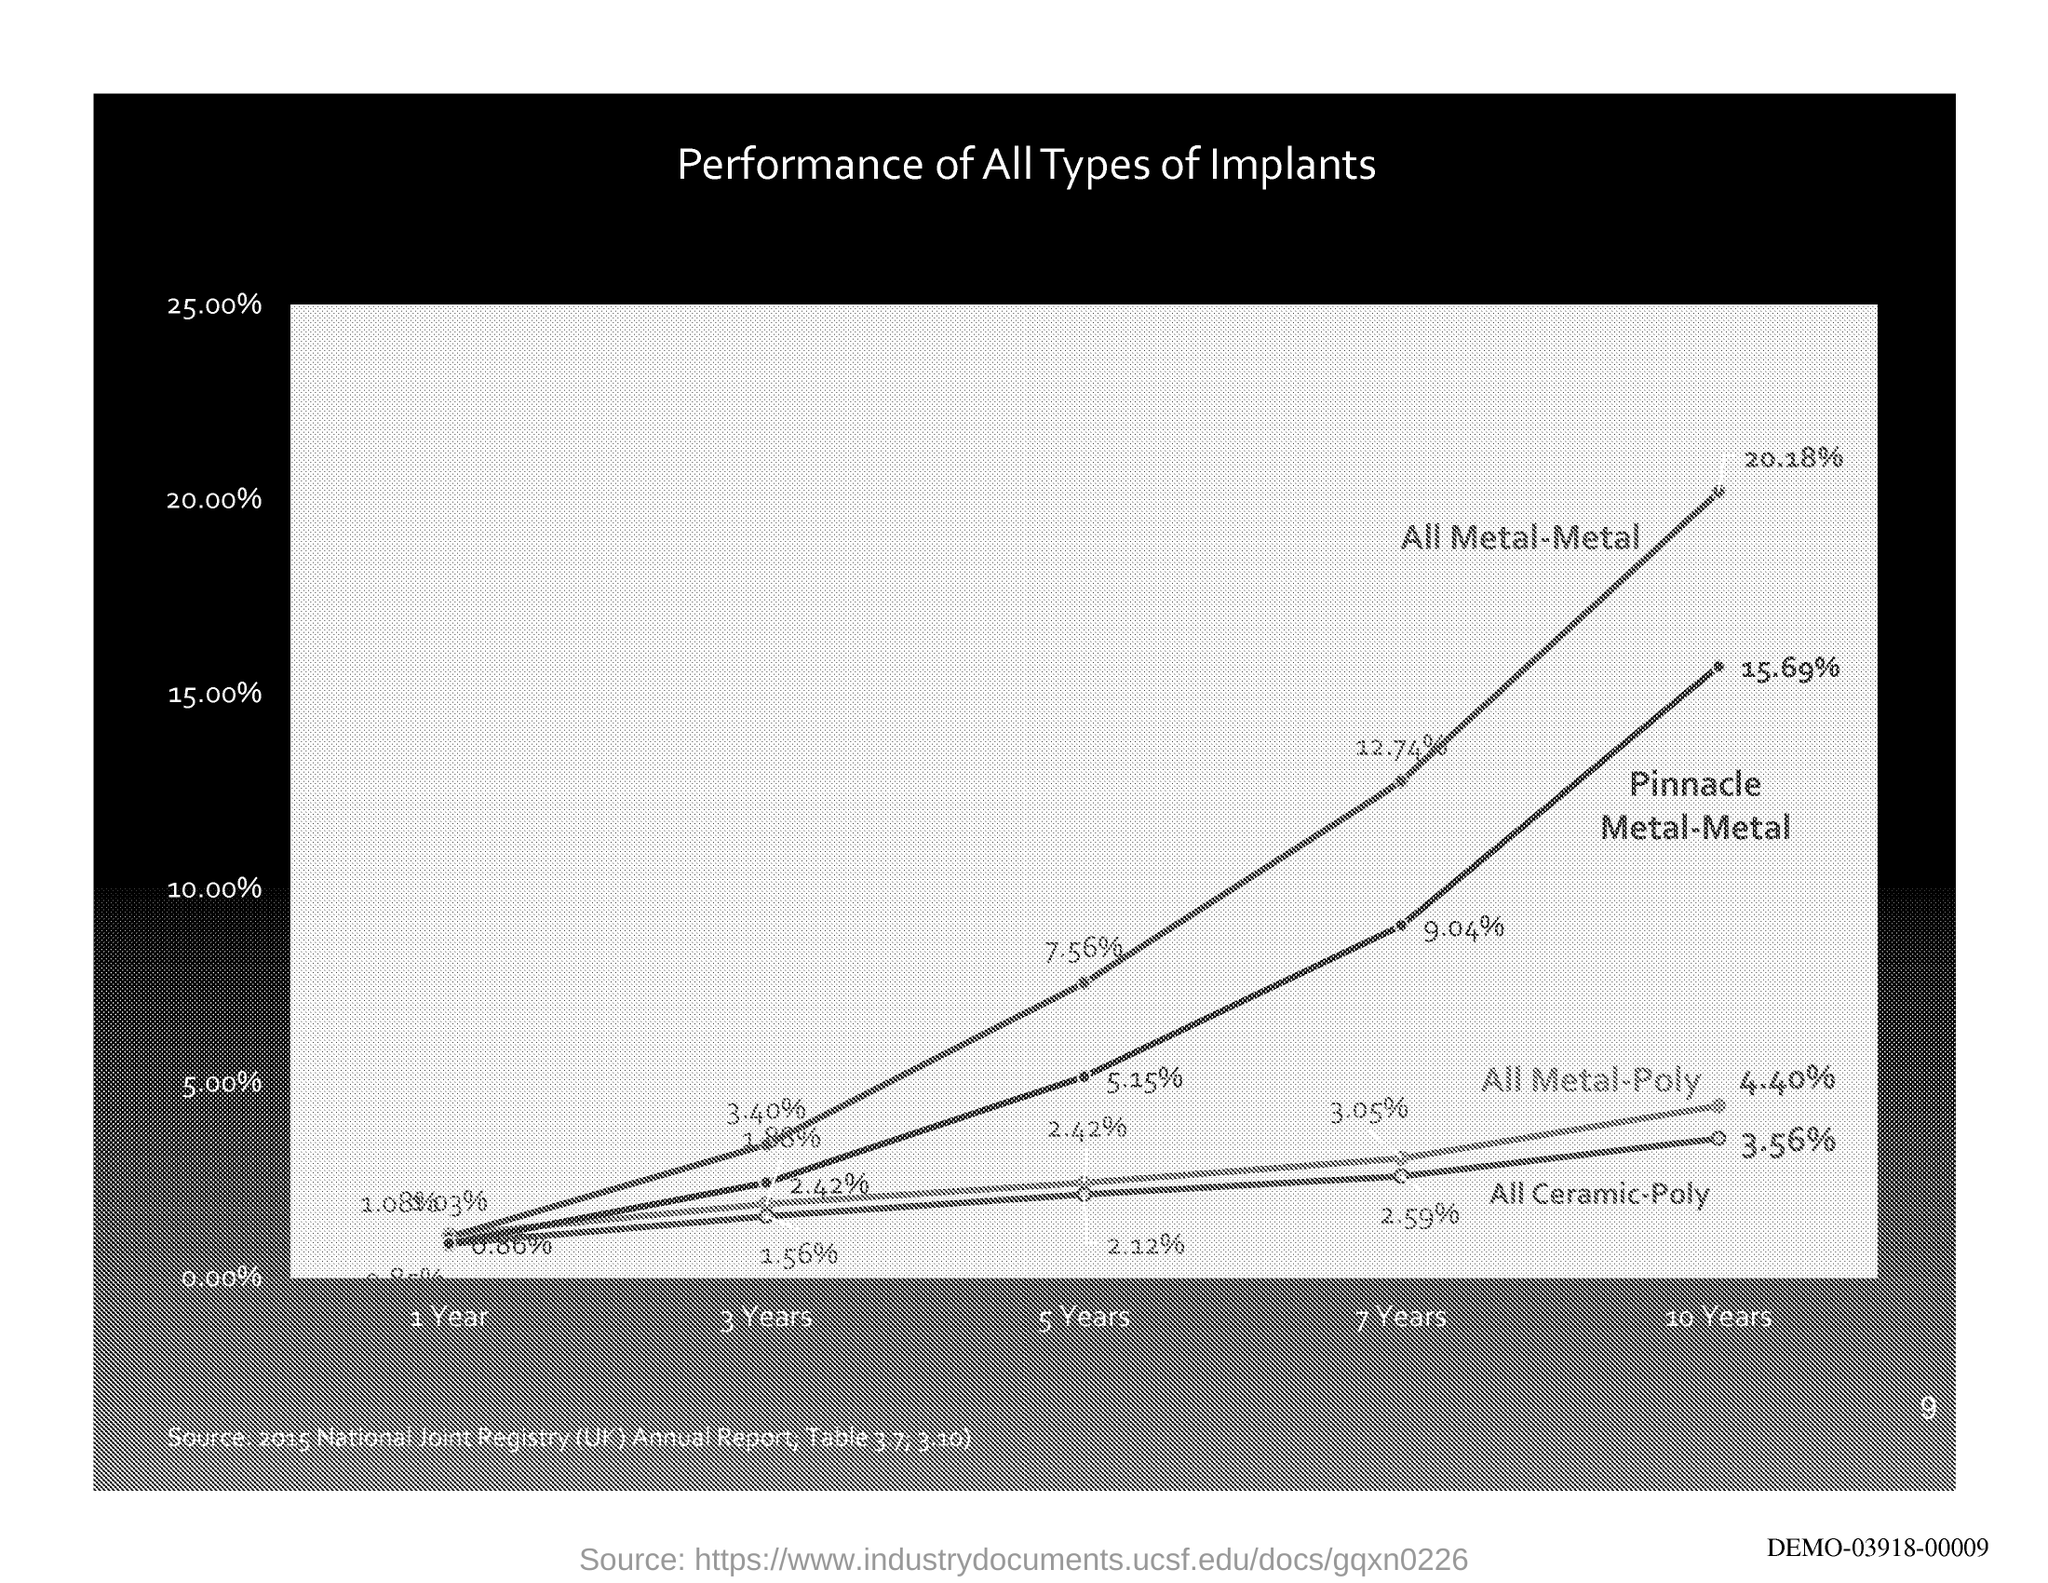What is the title of the graph shown?
Your answer should be very brief. Performance of All Types of Implants. 